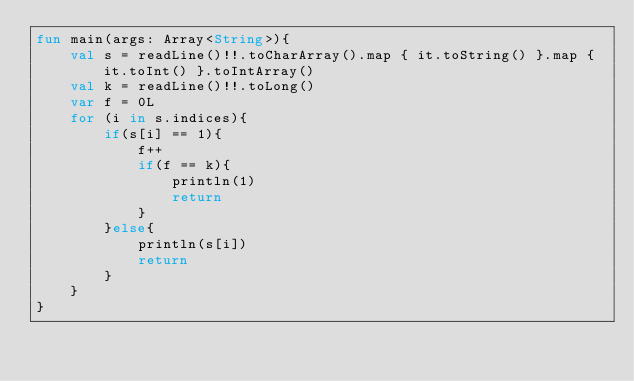Convert code to text. <code><loc_0><loc_0><loc_500><loc_500><_Kotlin_>fun main(args: Array<String>){
    val s = readLine()!!.toCharArray().map { it.toString() }.map { it.toInt() }.toIntArray()
    val k = readLine()!!.toLong()
    var f = 0L
    for (i in s.indices){
        if(s[i] == 1){
            f++
            if(f == k){
                println(1)
                return
            }
        }else{
            println(s[i])
            return
        }
    }
}</code> 